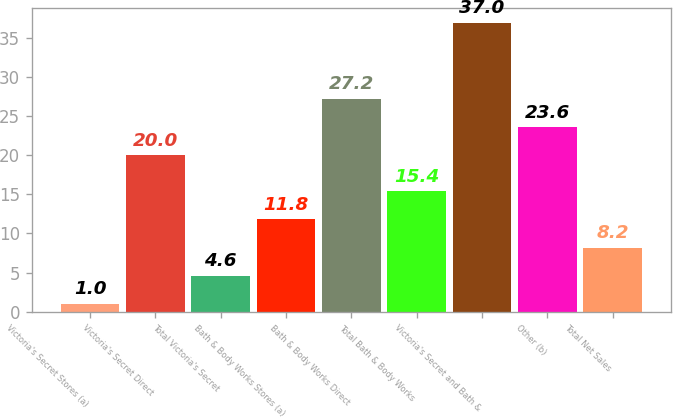<chart> <loc_0><loc_0><loc_500><loc_500><bar_chart><fcel>Victoria's Secret Stores (a)<fcel>Victoria's Secret Direct<fcel>Total Victoria's Secret<fcel>Bath & Body Works Stores (a)<fcel>Bath & Body Works Direct<fcel>Total Bath & Body Works<fcel>Victoria's Secret and Bath &<fcel>Other (b)<fcel>Total Net Sales<nl><fcel>1<fcel>20<fcel>4.6<fcel>11.8<fcel>27.2<fcel>15.4<fcel>37<fcel>23.6<fcel>8.2<nl></chart> 